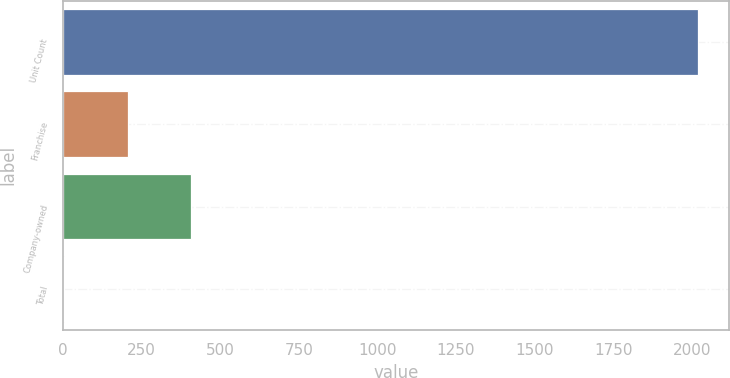Convert chart to OTSL. <chart><loc_0><loc_0><loc_500><loc_500><bar_chart><fcel>Unit Count<fcel>Franchise<fcel>Company-owned<fcel>Total<nl><fcel>2018<fcel>206.3<fcel>407.6<fcel>5<nl></chart> 